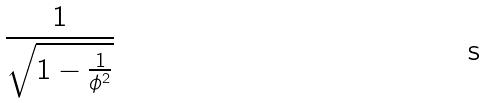<formula> <loc_0><loc_0><loc_500><loc_500>\frac { 1 } { \sqrt { 1 - \frac { 1 } { \phi ^ { 2 } } } }</formula> 